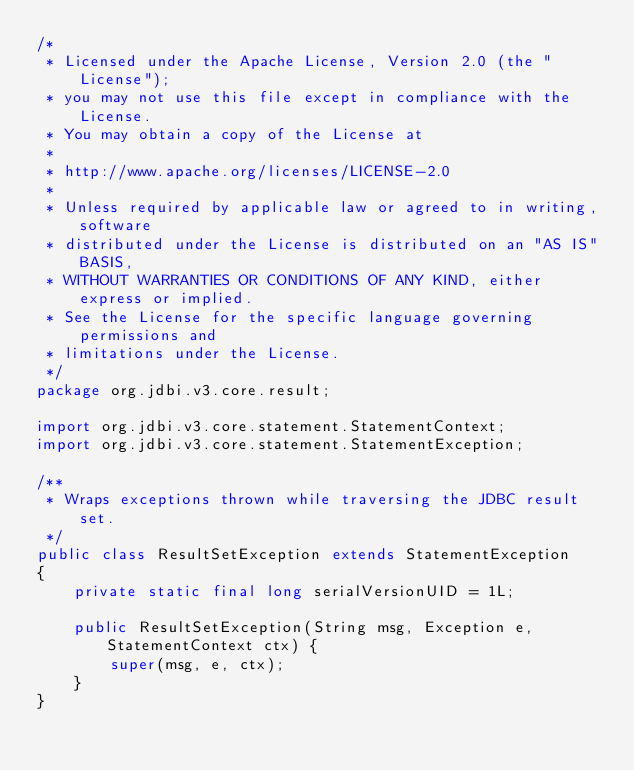Convert code to text. <code><loc_0><loc_0><loc_500><loc_500><_Java_>/*
 * Licensed under the Apache License, Version 2.0 (the "License");
 * you may not use this file except in compliance with the License.
 * You may obtain a copy of the License at
 *
 * http://www.apache.org/licenses/LICENSE-2.0
 *
 * Unless required by applicable law or agreed to in writing, software
 * distributed under the License is distributed on an "AS IS" BASIS,
 * WITHOUT WARRANTIES OR CONDITIONS OF ANY KIND, either express or implied.
 * See the License for the specific language governing permissions and
 * limitations under the License.
 */
package org.jdbi.v3.core.result;

import org.jdbi.v3.core.statement.StatementContext;
import org.jdbi.v3.core.statement.StatementException;

/**
 * Wraps exceptions thrown while traversing the JDBC result set.
 */
public class ResultSetException extends StatementException
{
    private static final long serialVersionUID = 1L;

    public ResultSetException(String msg, Exception e, StatementContext ctx) {
        super(msg, e, ctx);
    }
}
</code> 